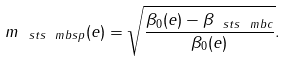Convert formula to latex. <formula><loc_0><loc_0><loc_500><loc_500>m _ { \ s t s \ m b { s p } } ( e ) = \sqrt { \frac { \beta _ { 0 } ( e ) - \beta _ { \ s t s \ m b { c } } } { \beta _ { 0 } ( e ) } } .</formula> 